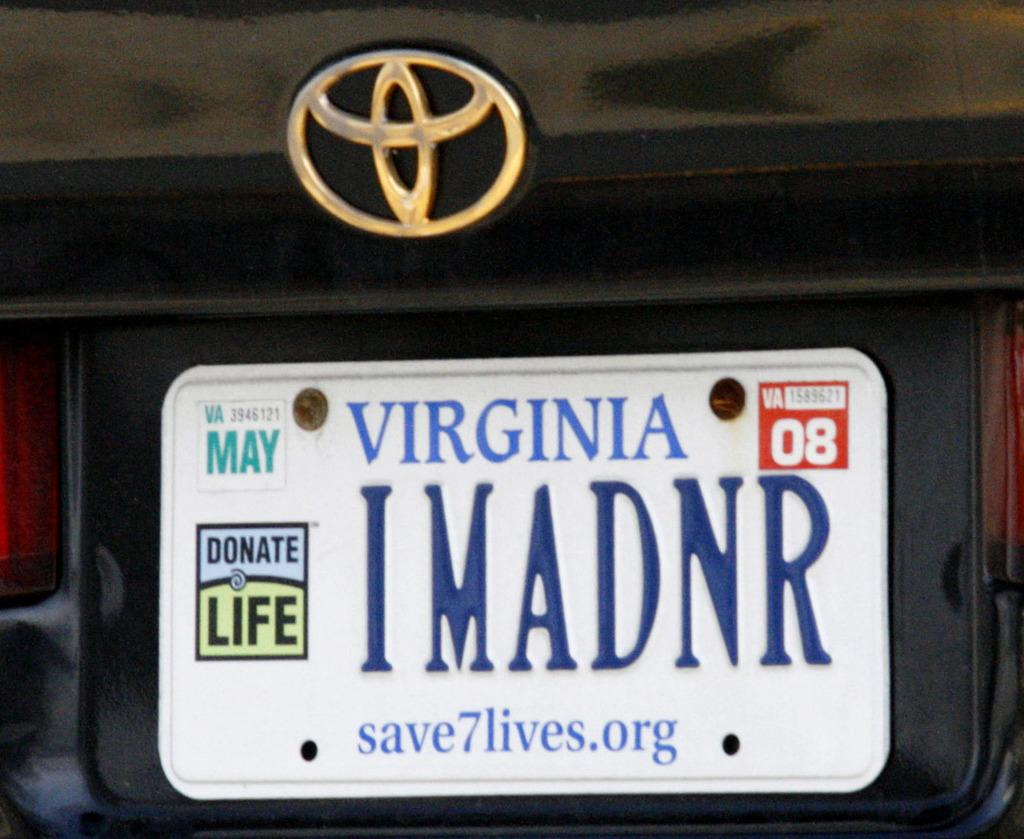Provide a one-sentence caption for the provided image. A Virginia licence plate with the number 08 visible. 